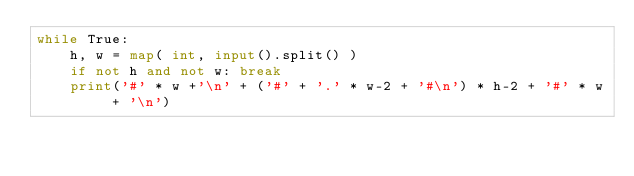Convert code to text. <code><loc_0><loc_0><loc_500><loc_500><_Python_>while True:
    h, w = map( int, input().split() )
    if not h and not w: break
    print('#' * w +'\n' + ('#' + '.' * w-2 + '#\n') * h-2 + '#' * w + '\n')</code> 